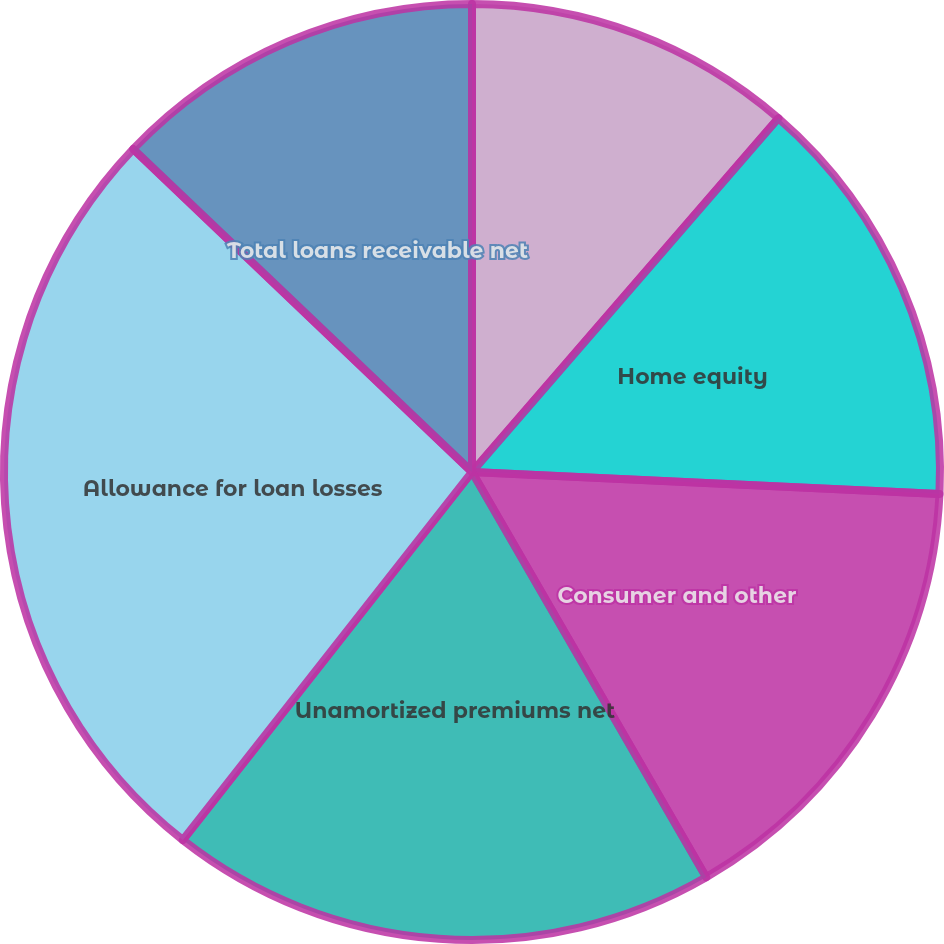<chart> <loc_0><loc_0><loc_500><loc_500><pie_chart><fcel>One- to four-family<fcel>Home equity<fcel>Consumer and other<fcel>Unamortized premiums net<fcel>Allowance for loan losses<fcel>Total loans receivable net<nl><fcel>11.36%<fcel>14.39%<fcel>15.91%<fcel>18.94%<fcel>26.52%<fcel>12.88%<nl></chart> 